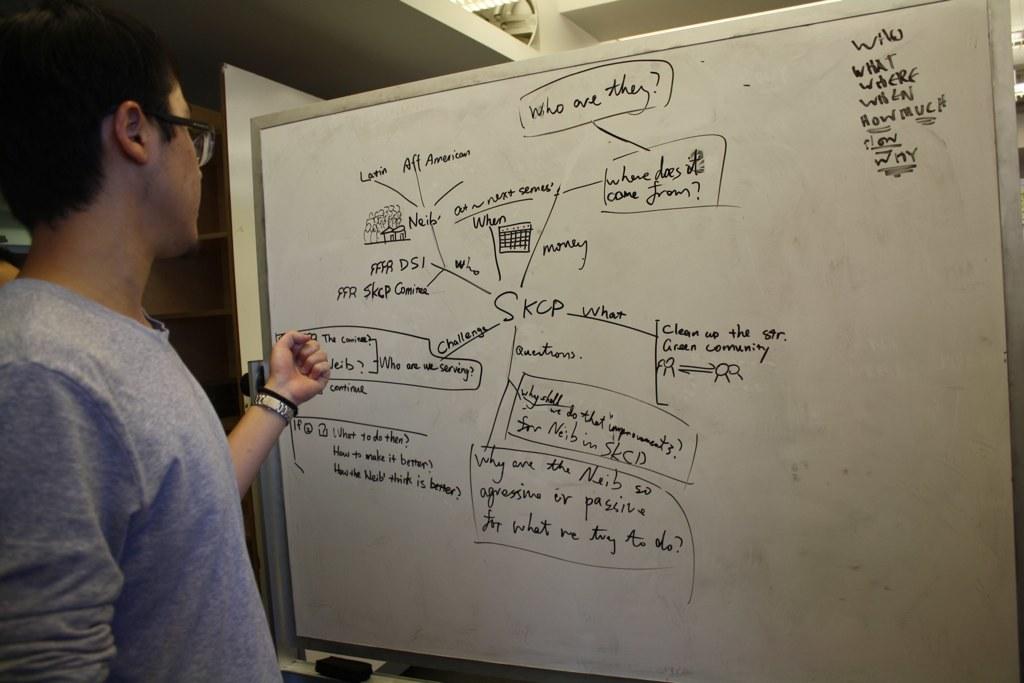Are they asking a who, what, where and why questions?
Your response must be concise. Yes. 